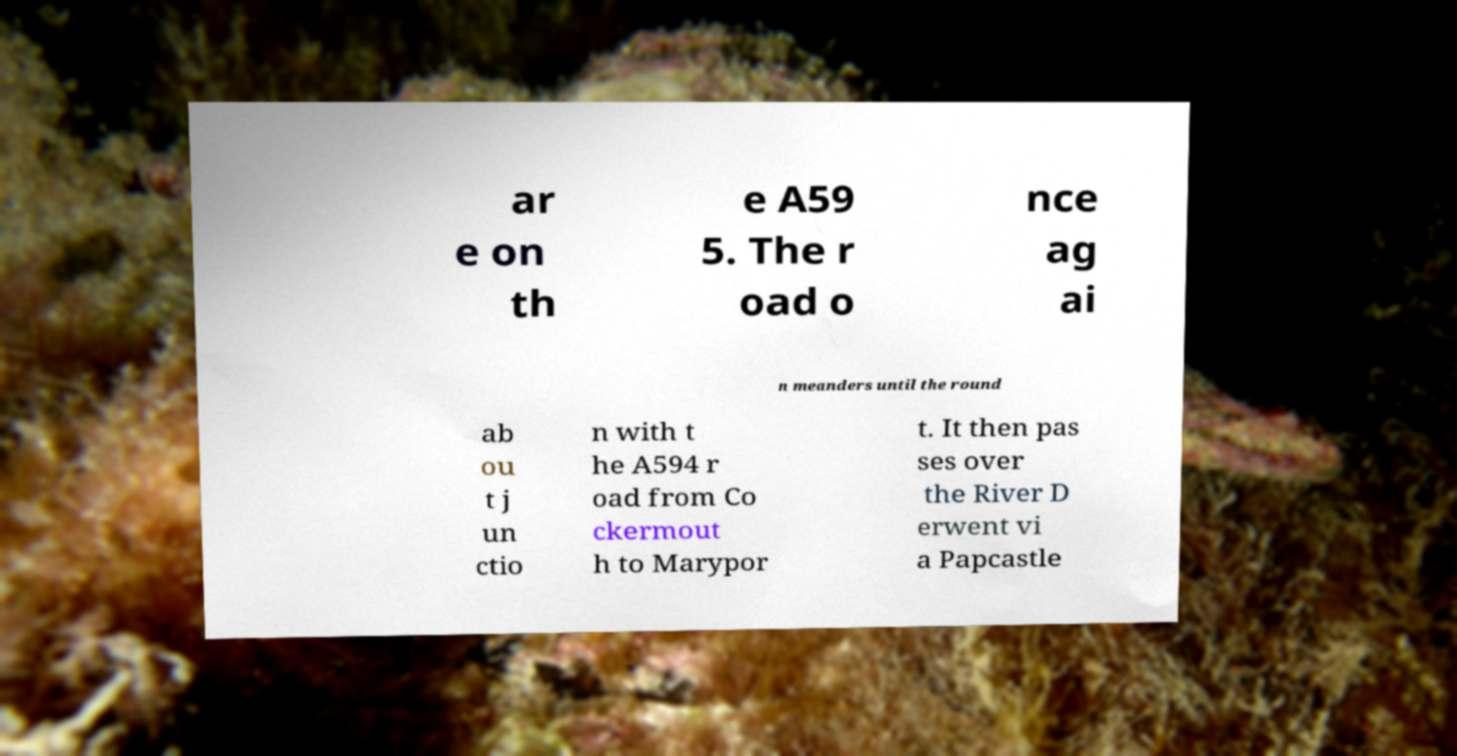There's text embedded in this image that I need extracted. Can you transcribe it verbatim? ar e on th e A59 5. The r oad o nce ag ai n meanders until the round ab ou t j un ctio n with t he A594 r oad from Co ckermout h to Marypor t. It then pas ses over the River D erwent vi a Papcastle 